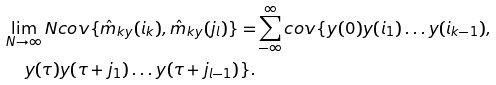<formula> <loc_0><loc_0><loc_500><loc_500>\lim _ { N \to \infty } N c o v \{ \hat { m } _ { k y } ( i _ { k } ) , \hat { m } _ { k y } ( j _ { l } ) \} = & \sum _ { - \infty } ^ { \infty } c o v \{ y ( 0 ) y ( i _ { 1 } ) \dots y ( i _ { k - 1 } ) , \\ y ( \tau ) y ( \tau + j _ { 1 } ) \dots y ( \tau + j _ { l - 1 } ) \} .</formula> 